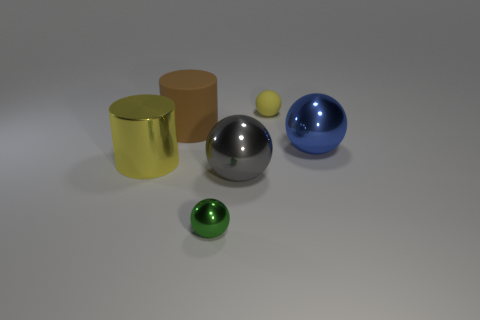Is there anything else that has the same shape as the brown matte object?
Offer a very short reply. Yes. Is the size of the yellow object left of the gray metallic sphere the same as the gray metal ball?
Offer a terse response. Yes. What number of matte objects are either large gray spheres or tiny gray cylinders?
Your answer should be compact. 0. There is a sphere to the right of the yellow matte object; how big is it?
Ensure brevity in your answer.  Large. Do the green metal thing and the yellow matte object have the same shape?
Your response must be concise. Yes. What number of large things are blue rubber spheres or green spheres?
Make the answer very short. 0. Are there any large gray metal objects to the right of the yellow metallic cylinder?
Give a very brief answer. Yes. Are there an equal number of big brown rubber things in front of the gray object and tiny green metallic things?
Your answer should be compact. No. The blue thing that is the same shape as the small green metal object is what size?
Ensure brevity in your answer.  Large. There is a large yellow metal object; does it have the same shape as the small object behind the green shiny object?
Keep it short and to the point. No. 